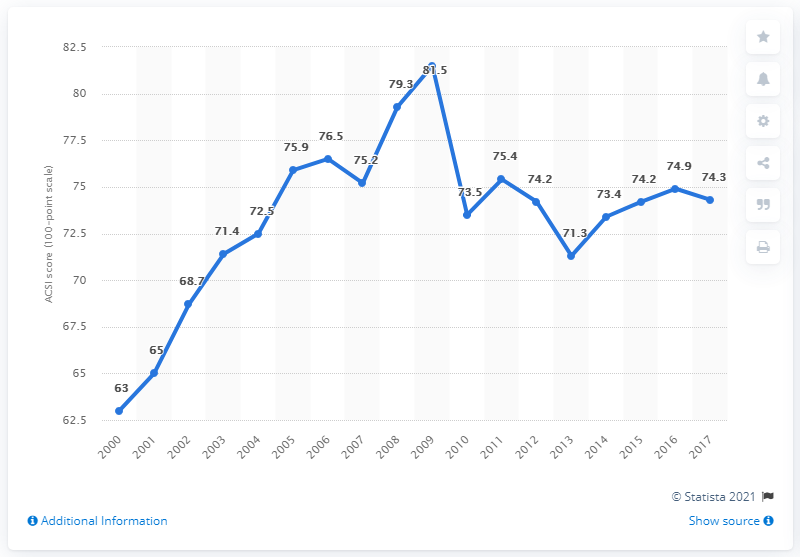What was the score for customer satisfaction with e-business in 2017?
 74.3 